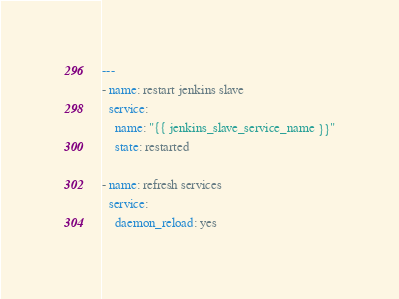Convert code to text. <code><loc_0><loc_0><loc_500><loc_500><_YAML_>---
- name: restart jenkins slave
  service:
    name: "{{ jenkins_slave_service_name }}"
    state: restarted

- name: refresh services
  service:
    daemon_reload: yes
</code> 